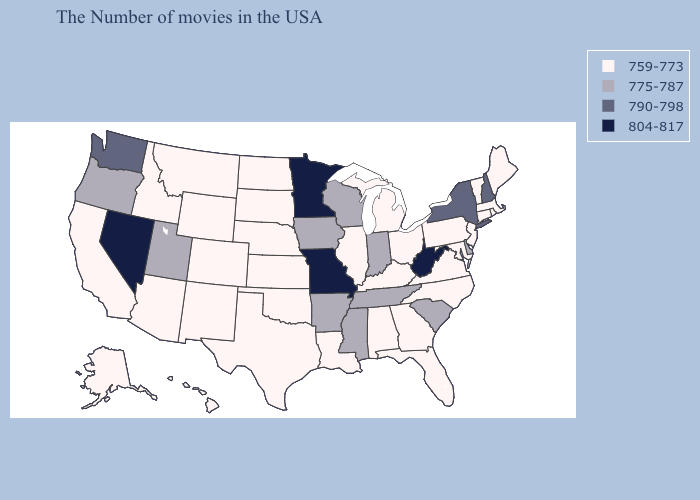Among the states that border Illinois , does Kentucky have the highest value?
Short answer required. No. What is the highest value in states that border Kansas?
Keep it brief. 804-817. Name the states that have a value in the range 775-787?
Keep it brief. Delaware, South Carolina, Indiana, Tennessee, Wisconsin, Mississippi, Arkansas, Iowa, Utah, Oregon. What is the lowest value in the USA?
Be succinct. 759-773. What is the value of Illinois?
Be succinct. 759-773. What is the highest value in the USA?
Answer briefly. 804-817. What is the highest value in the MidWest ?
Keep it brief. 804-817. What is the value of Maine?
Concise answer only. 759-773. What is the lowest value in the USA?
Concise answer only. 759-773. Among the states that border North Dakota , does Minnesota have the highest value?
Answer briefly. Yes. Does North Dakota have the lowest value in the MidWest?
Short answer required. Yes. Is the legend a continuous bar?
Quick response, please. No. What is the value of Wisconsin?
Be succinct. 775-787. What is the lowest value in the USA?
Be succinct. 759-773. Does Louisiana have the lowest value in the USA?
Short answer required. Yes. 